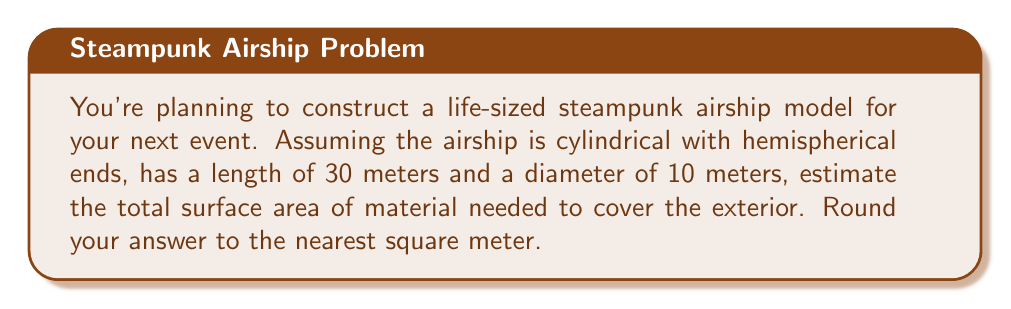Solve this math problem. Let's break this down step-by-step:

1) The airship consists of three parts: a cylindrical body and two hemispherical ends.

2) For the cylindrical body:
   - Surface area = $\pi d h$, where $d$ is diameter and $h$ is height
   - The height of the cylinder is the total length minus the diameter: $30m - 10m = 20m$
   - Surface area of cylinder = $\pi \cdot 10m \cdot 20m = 200\pi$ m²

3) For each hemispherical end:
   - Surface area of a hemisphere = $2\pi r^2$, where $r$ is radius
   - Radius = diameter / 2 = $10m / 2 = 5m$
   - Surface area of one hemisphere = $2\pi \cdot (5m)^2 = 50\pi$ m²
   - There are two hemispheres, so total = $100\pi$ m²

4) Total surface area:
   $$ \text{Total Area} = 200\pi + 100\pi = 300\pi \text{ m²} $$

5) Converting to a numerical value:
   $$ 300\pi \approx 942.48 \text{ m²} $$

6) Rounding to the nearest square meter:
   $$ 942.48 \text{ m²} \approx 942 \text{ m²} $$

Therefore, you would need approximately 942 square meters of material to cover the exterior of the airship model.
Answer: 942 m² 